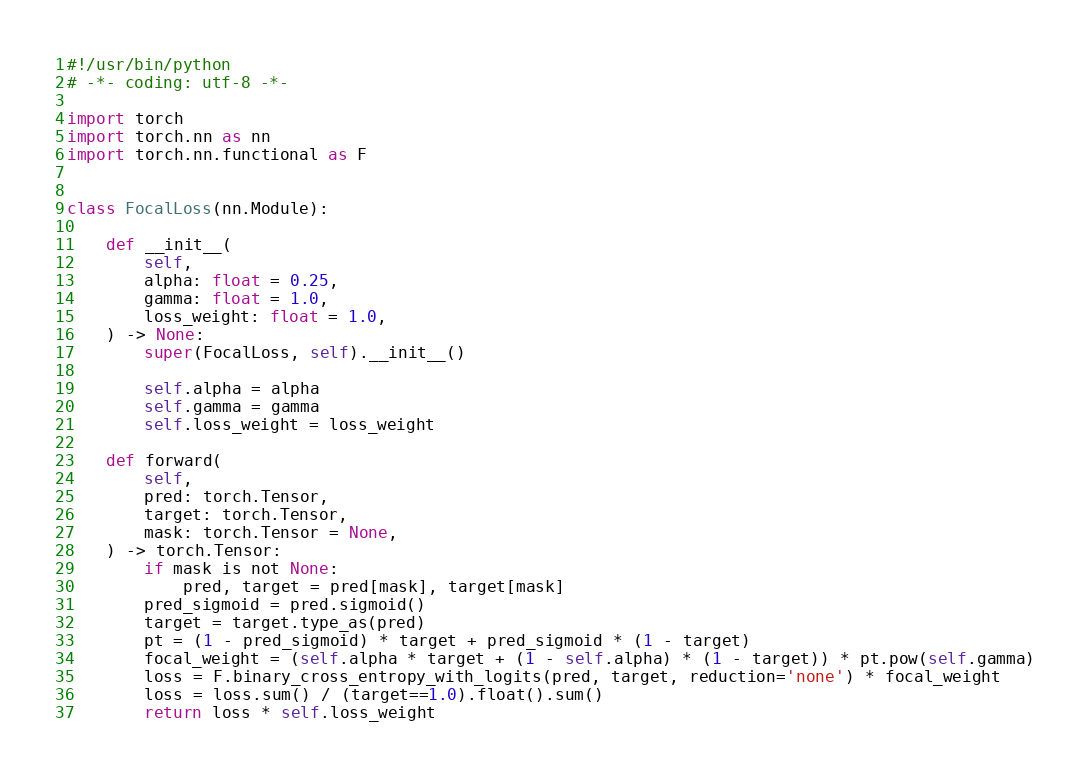<code> <loc_0><loc_0><loc_500><loc_500><_Python_>#!/usr/bin/python
# -*- coding: utf-8 -*-

import torch
import torch.nn as nn
import torch.nn.functional as F


class FocalLoss(nn.Module):

    def __init__(
        self,
        alpha: float = 0.25,
        gamma: float = 1.0,
        loss_weight: float = 1.0,
    ) -> None:
        super(FocalLoss, self).__init__()

        self.alpha = alpha
        self.gamma = gamma
        self.loss_weight = loss_weight

    def forward(
        self,
        pred: torch.Tensor,
        target: torch.Tensor,
        mask: torch.Tensor = None,
    ) -> torch.Tensor:
        if mask is not None:
            pred, target = pred[mask], target[mask]
        pred_sigmoid = pred.sigmoid()
        target = target.type_as(pred)
        pt = (1 - pred_sigmoid) * target + pred_sigmoid * (1 - target)
        focal_weight = (self.alpha * target + (1 - self.alpha) * (1 - target)) * pt.pow(self.gamma)
        loss = F.binary_cross_entropy_with_logits(pred, target, reduction='none') * focal_weight
        loss = loss.sum() / (target==1.0).float().sum()
        return loss * self.loss_weight
</code> 